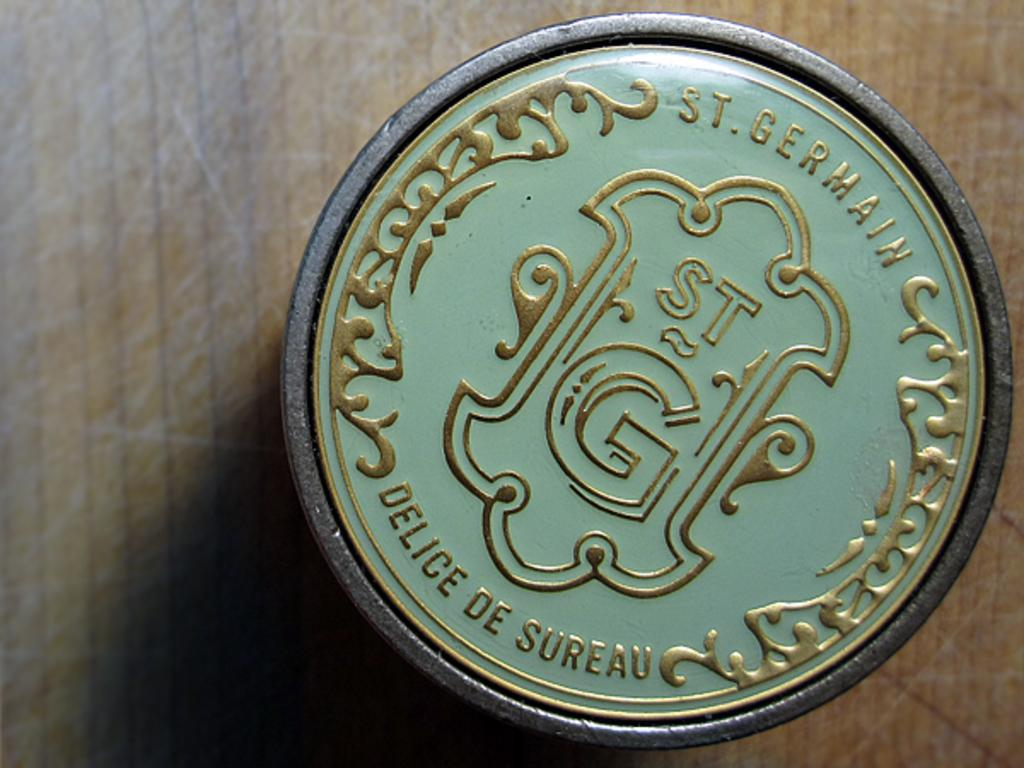<image>
Describe the image concisely. A button with a decorative gold and white logo for St. Germain 